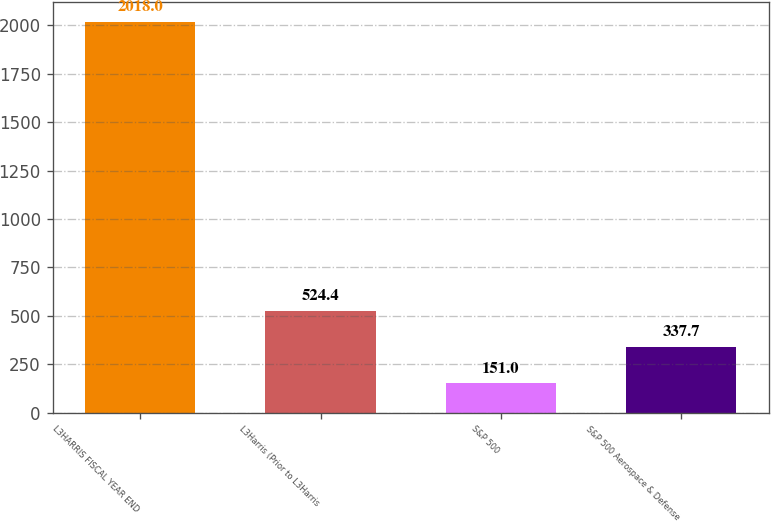Convert chart to OTSL. <chart><loc_0><loc_0><loc_500><loc_500><bar_chart><fcel>L3HARRIS FISCAL YEAR END<fcel>L3Harris (Prior to L3Harris<fcel>S&P 500<fcel>S&P 500 Aerospace & Defense<nl><fcel>2018<fcel>524.4<fcel>151<fcel>337.7<nl></chart> 